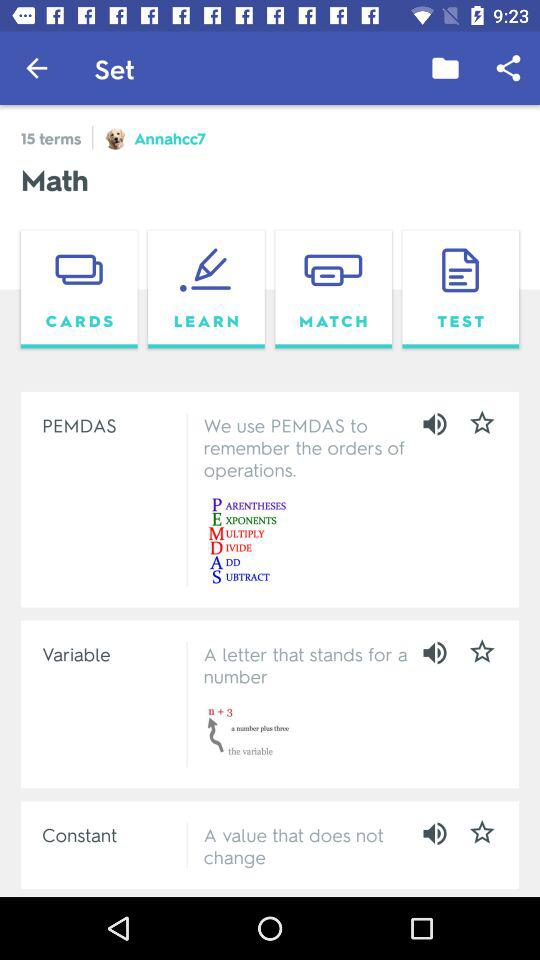What is the name of the subject? The name of the subject is math. 